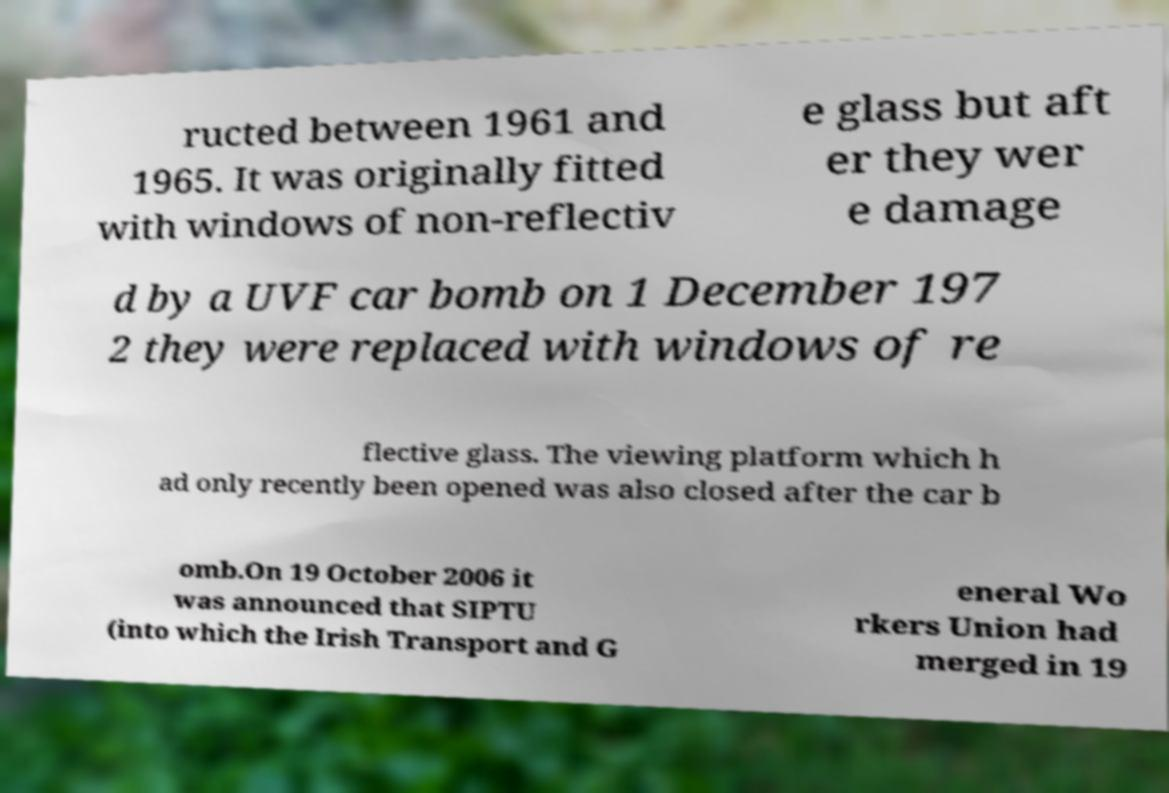What messages or text are displayed in this image? I need them in a readable, typed format. ructed between 1961 and 1965. It was originally fitted with windows of non-reflectiv e glass but aft er they wer e damage d by a UVF car bomb on 1 December 197 2 they were replaced with windows of re flective glass. The viewing platform which h ad only recently been opened was also closed after the car b omb.On 19 October 2006 it was announced that SIPTU (into which the Irish Transport and G eneral Wo rkers Union had merged in 19 